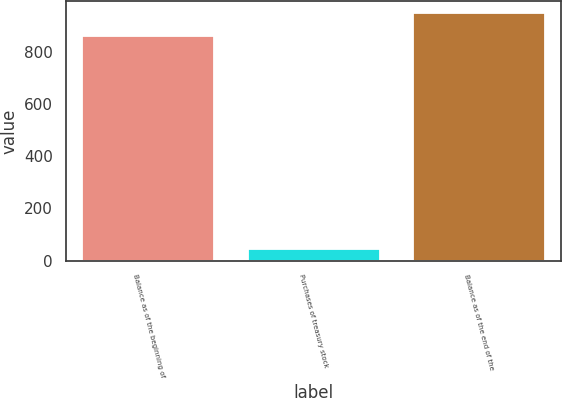Convert chart. <chart><loc_0><loc_0><loc_500><loc_500><bar_chart><fcel>Balance as of the beginning of<fcel>Purchases of treasury stock<fcel>Balance as of the end of the<nl><fcel>860<fcel>45<fcel>946<nl></chart> 